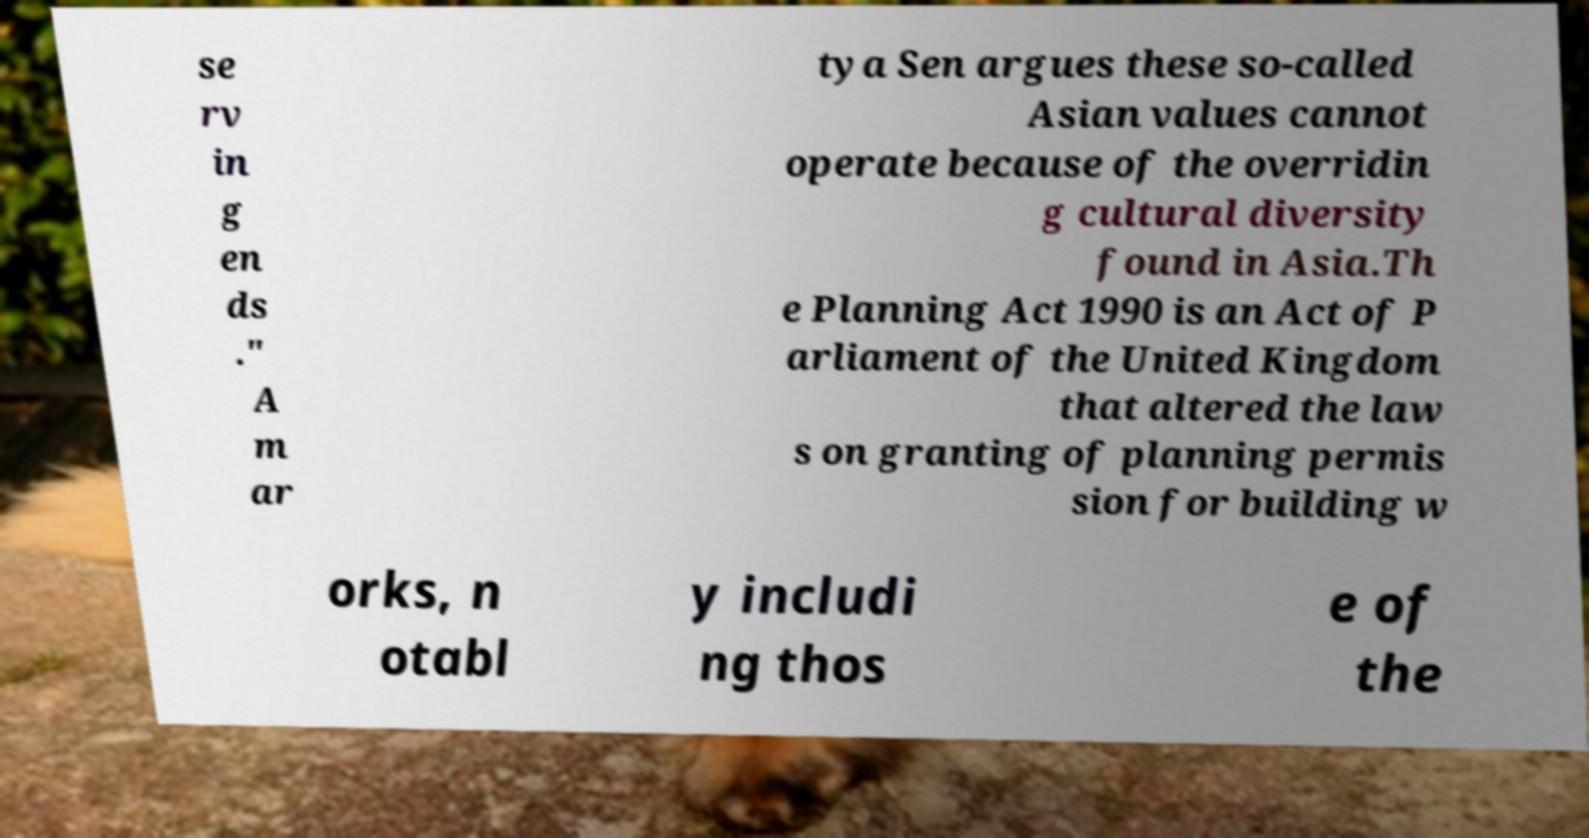Please read and relay the text visible in this image. What does it say? se rv in g en ds ." A m ar tya Sen argues these so-called Asian values cannot operate because of the overridin g cultural diversity found in Asia.Th e Planning Act 1990 is an Act of P arliament of the United Kingdom that altered the law s on granting of planning permis sion for building w orks, n otabl y includi ng thos e of the 